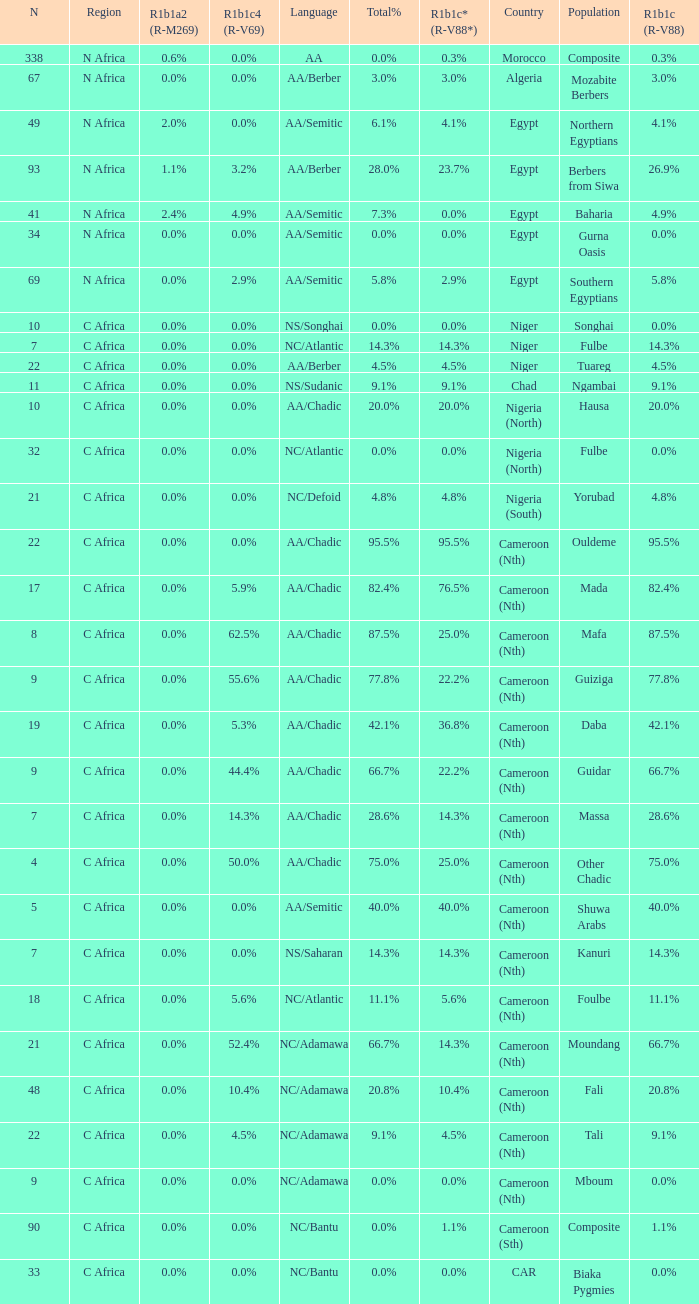What languages are spoken in Niger with r1b1c (r-v88) of 0.0%? NS/Songhai. 